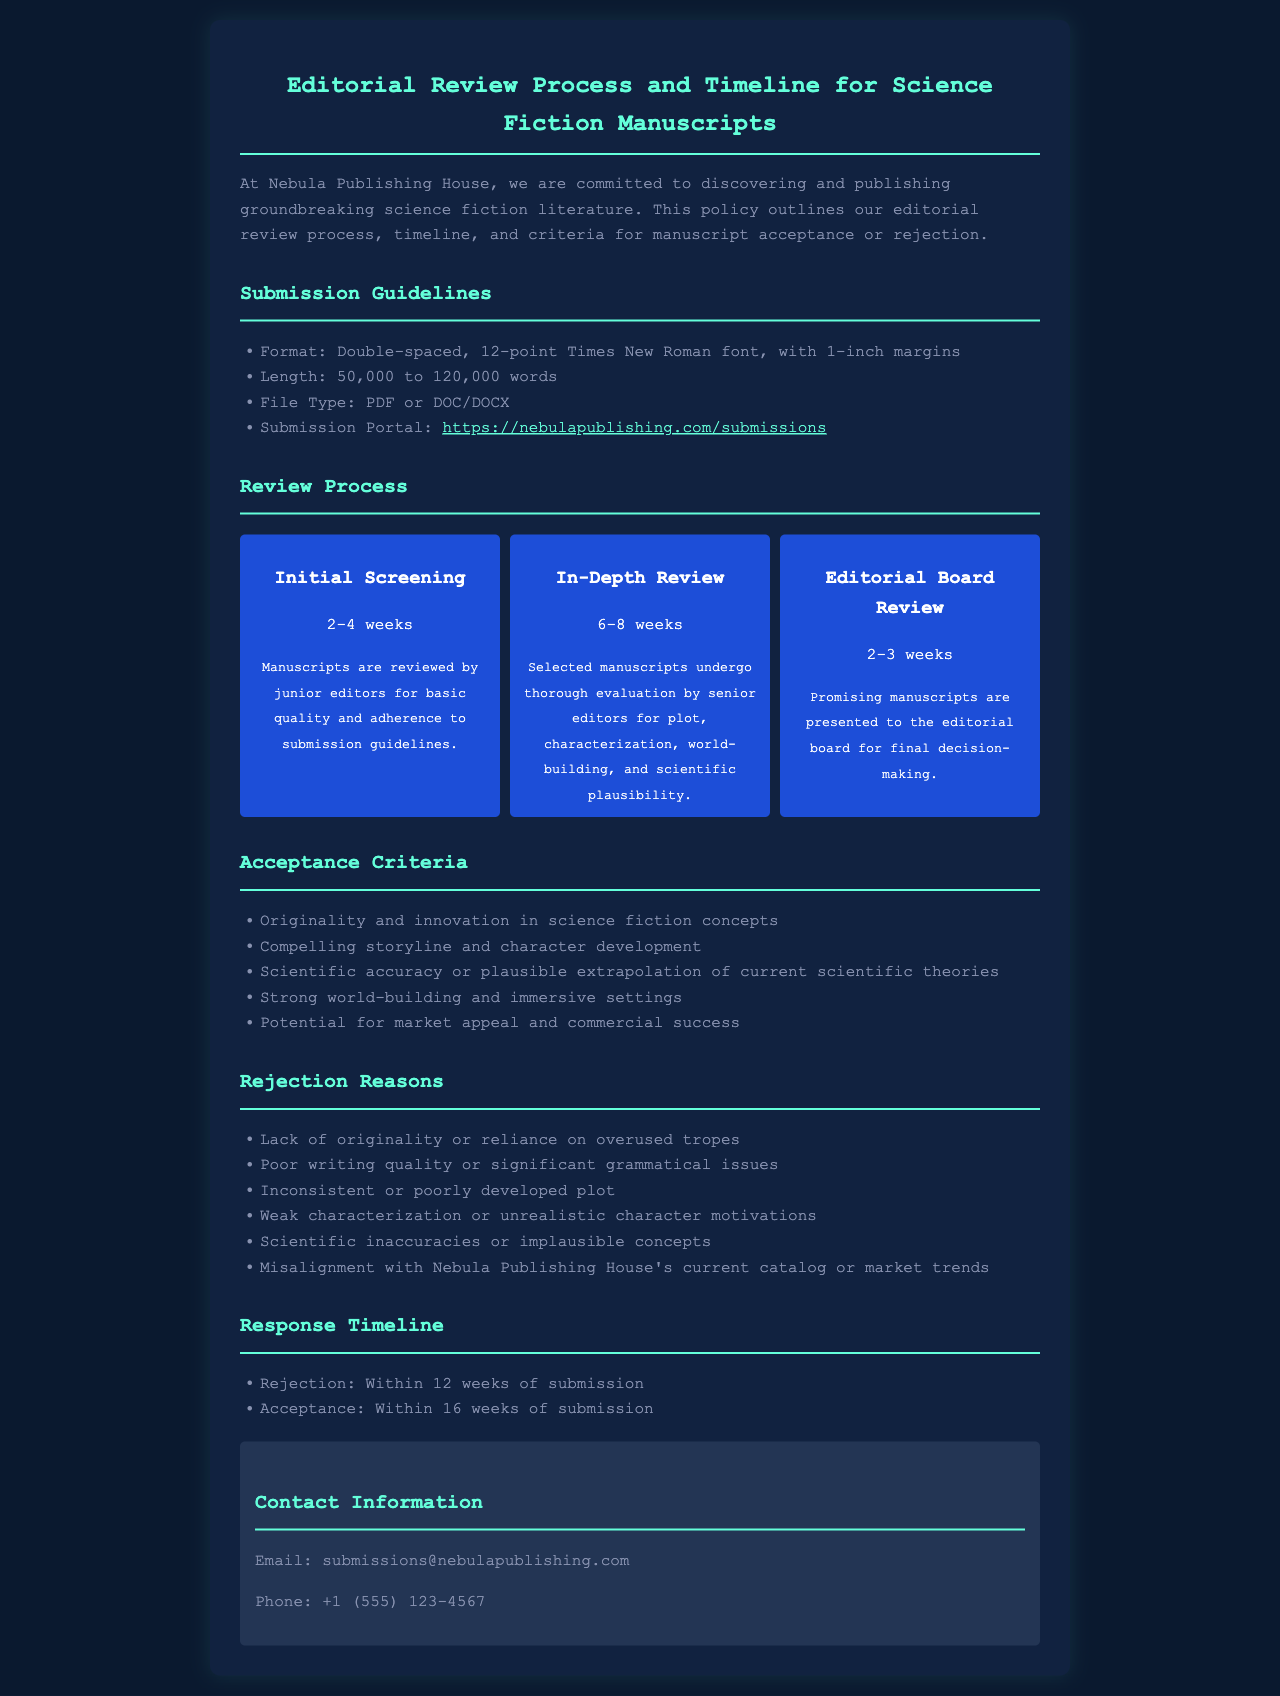What is the required length for manuscripts? The document specifies that the length must be between 50,000 to 120,000 words.
Answer: 50,000 to 120,000 words How long does the initial screening take? The timeline section states that the initial screening takes 2-4 weeks.
Answer: 2-4 weeks What are the rejection reasons related to scientific concepts? The document lists scientific inaccuracies or implausible concepts as a rejection reason.
Answer: Scientific inaccuracies or implausible concepts What is the response time for acceptance? The document indicates that acceptance notifications are made within 16 weeks of submission.
Answer: 16 weeks Who evaluates the manuscripts during the in-depth review? The document mentions that senior editors conduct the in-depth review.
Answer: Senior editors What is one criterion for acceptance related to originality? The criteria specify originality and innovation in science fiction concepts as an acceptance criterion.
Answer: Originality and innovation in science fiction concepts What format is required for manuscript submissions? The submission guidelines state that manuscripts must be in double-spaced format using 12-point Times New Roman font.
Answer: Double-spaced, 12-point Times New Roman font How many weeks does the editorial board review take? The timeline indicates that the editorial board review takes 2-3 weeks.
Answer: 2-3 weeks 